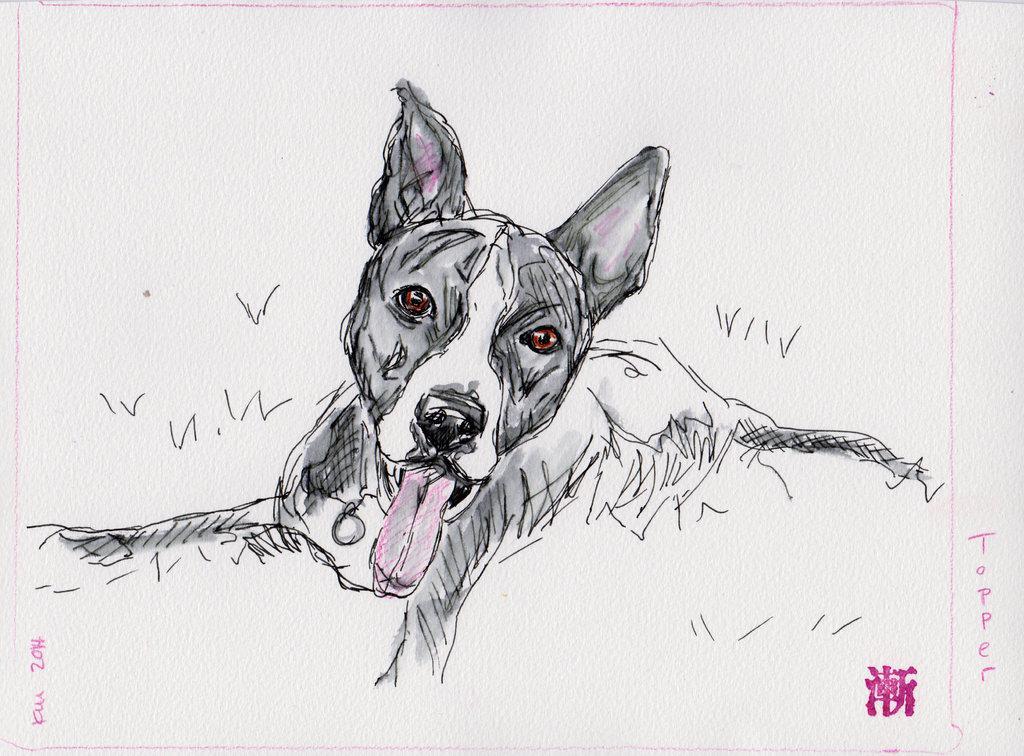In one or two sentences, can you explain what this image depicts? There is a sketch of a dog on a white color sheet as we can see in the middle of this image. 